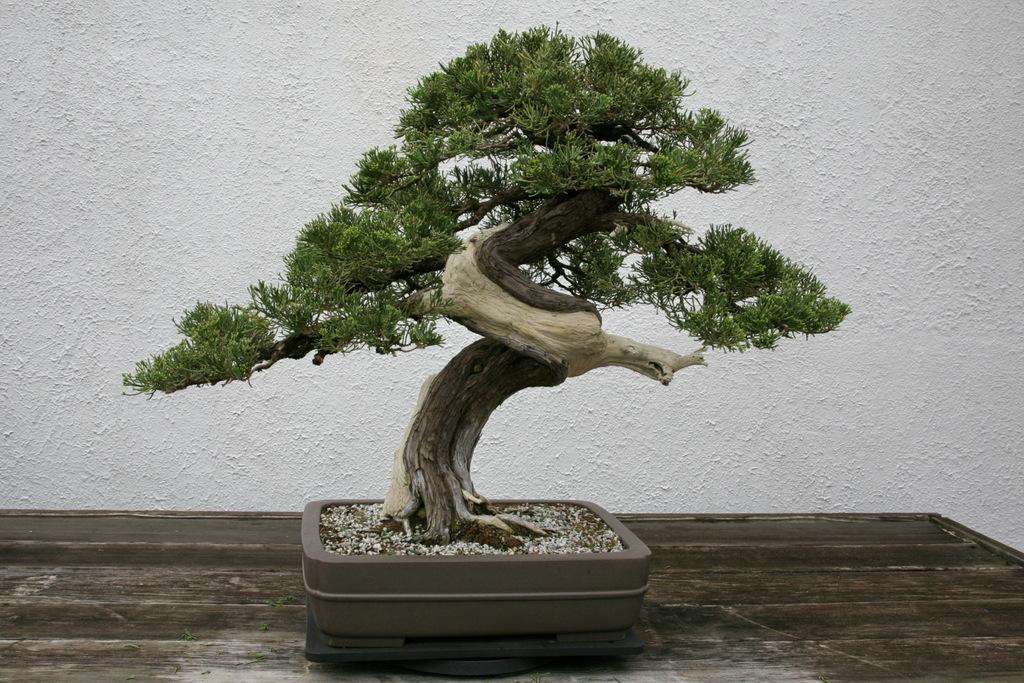In one or two sentences, can you explain what this image depicts? We can see tree. On the background we can see wall. 